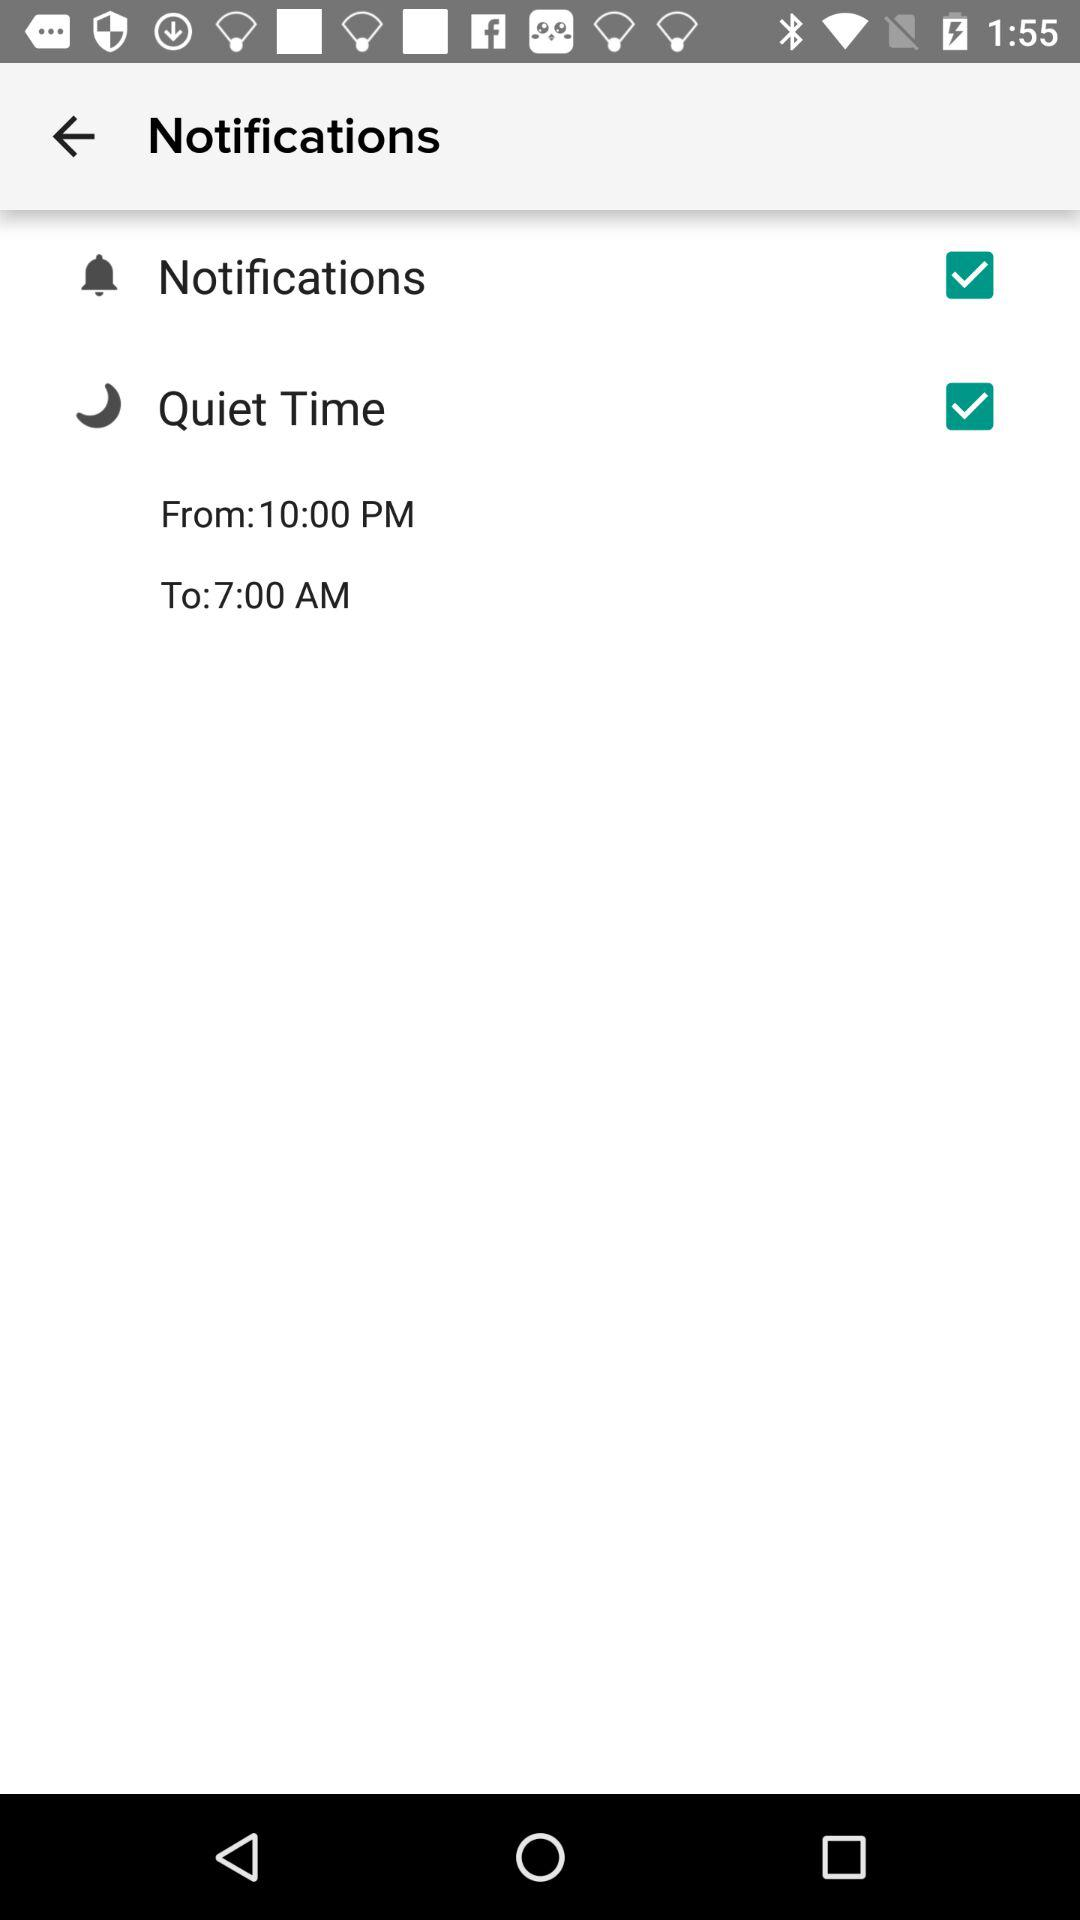What is the starting time of "Quiet Time"? The starting time of "Quiet Time" is 10:00 PM. 